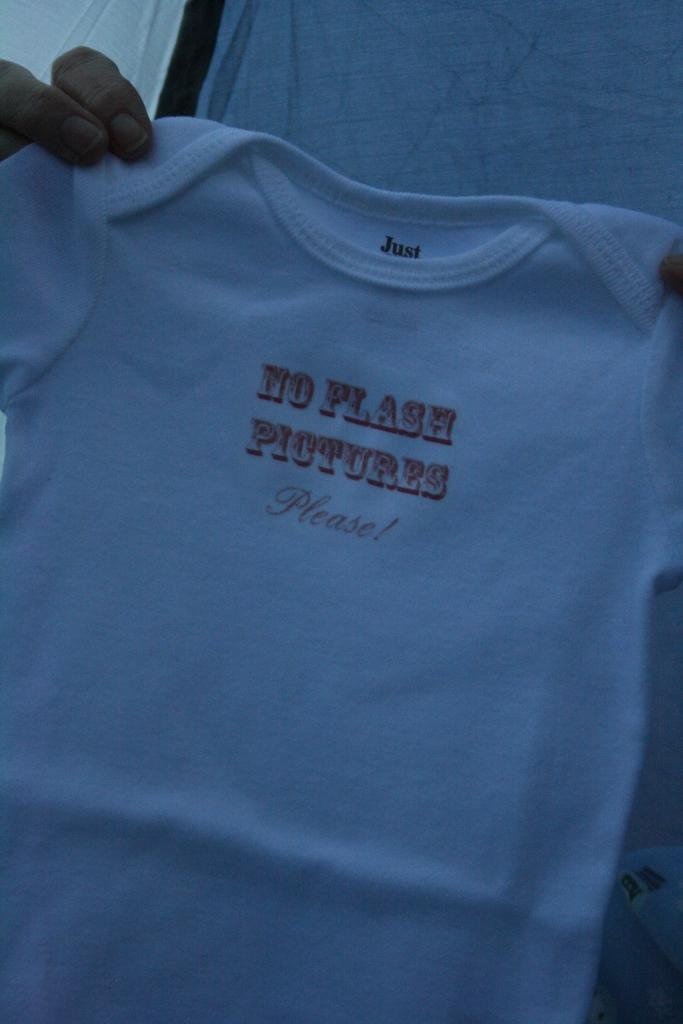<image>
Summarize the visual content of the image. A small tshirt that has the text "no flash pictures please" on the center of it. 